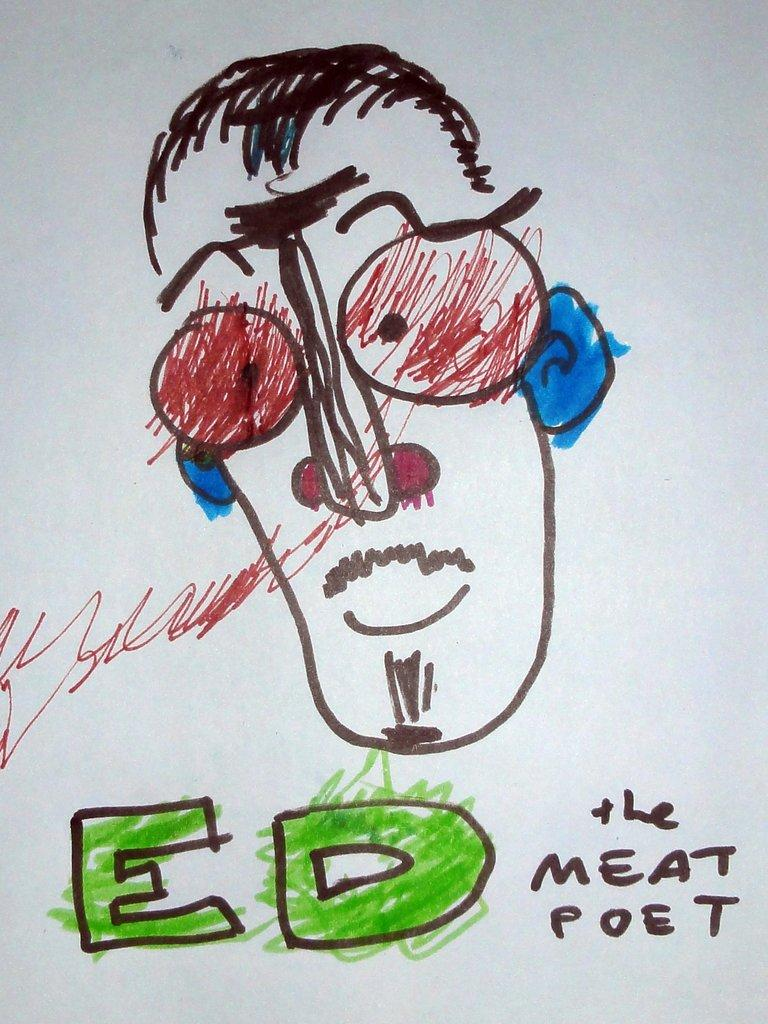What is the main subject of the image? The main subject of the image is a drawing. What else can be seen in the image besides the drawing? There is text written on a paper in the image. What type of card is being used to play a game in the image? There is no card or game present in the image; it only features a drawing and text written on a paper. 